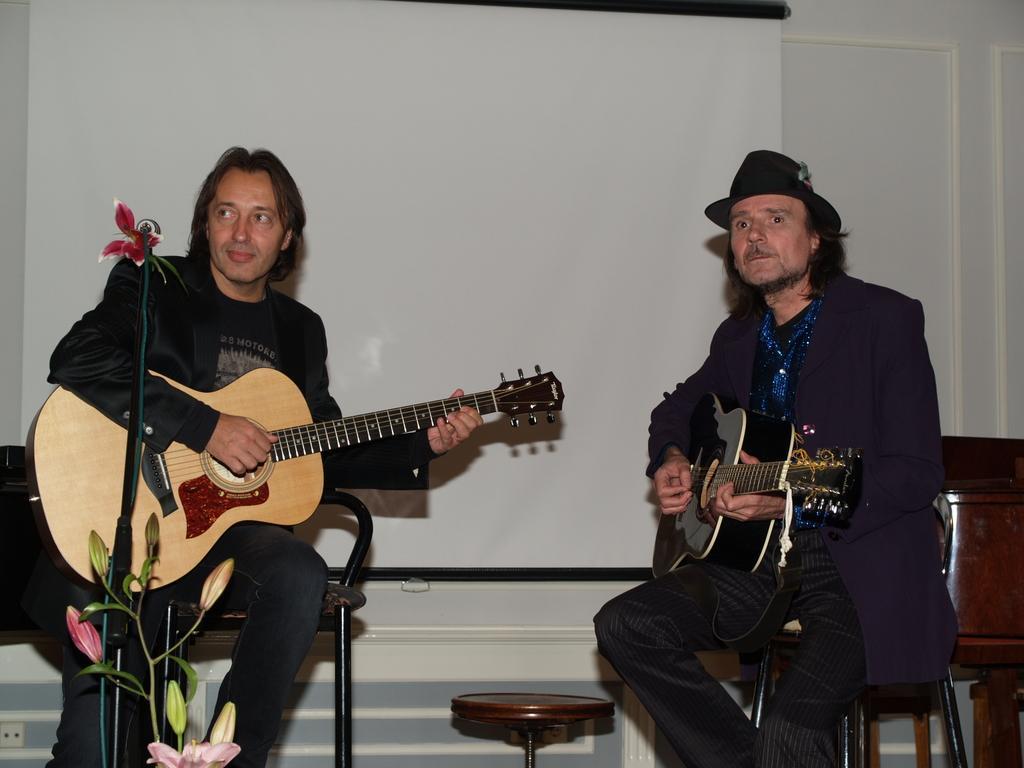How would you summarize this image in a sentence or two? Two persons sitting on the chair playing guitar ,here there is white color. 